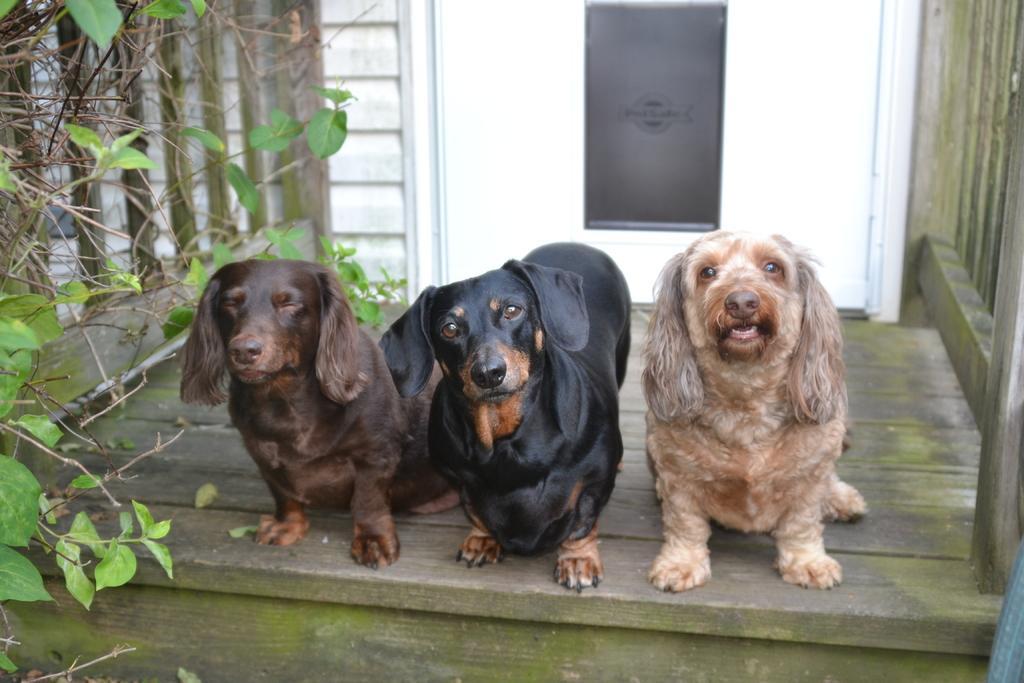Describe this image in one or two sentences. In this image, we can see some dogs on the wooden surface. We can see the wall with a white colored object. We can also see the fence and some leaves on the left. We can also see an object on the bottom right corner. 